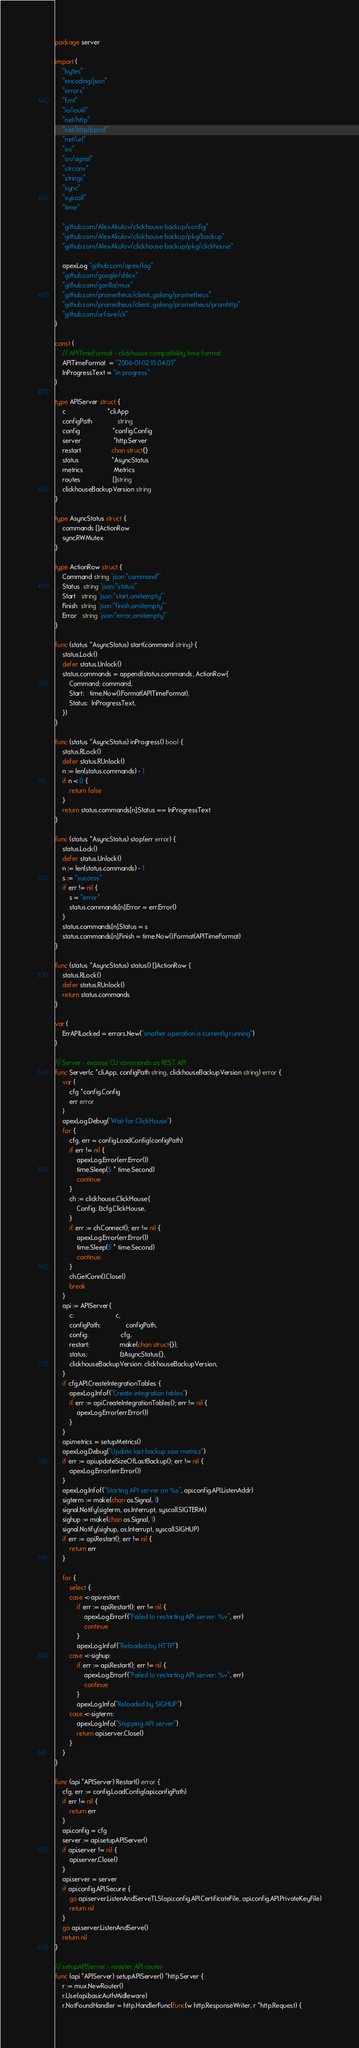Convert code to text. <code><loc_0><loc_0><loc_500><loc_500><_Go_>package server

import (
	"bytes"
	"encoding/json"
	"errors"
	"fmt"
	"io/ioutil"
	"net/http"
	"net/http/pprof"
	"net/url"
	"os"
	"os/signal"
	"strconv"
	"strings"
	"sync"
	"syscall"
	"time"

	"github.com/AlexAkulov/clickhouse-backup/config"
	"github.com/AlexAkulov/clickhouse-backup/pkg/backup"
	"github.com/AlexAkulov/clickhouse-backup/pkg/clickhouse"

	apexLog "github.com/apex/log"
	"github.com/google/shlex"
	"github.com/gorilla/mux"
	"github.com/prometheus/client_golang/prometheus"
	"github.com/prometheus/client_golang/prometheus/promhttp"
	"github.com/urfave/cli"
)

const (
	// APITimeFormat - clickhouse compatibility time format
	APITimeFormat  = "2006-01-02 15:04:05"
	InProgressText = "in progress"
)

type APIServer struct {
	c                       *cli.App
	configPath              string
	config                  *config.Config
	server                  *http.Server
	restart                 chan struct{}
	status                  *AsyncStatus
	metrics                 Metrics
	routes                  []string
	clickhouseBackupVersion string
}

type AsyncStatus struct {
	commands []ActionRow
	sync.RWMutex
}

type ActionRow struct {
	Command string `json:"command"`
	Status  string `json:"status"`
	Start   string `json:"start,omitempty"`
	Finish  string `json:"finish,omitempty"`
	Error   string `json:"error,omitempty"`
}

func (status *AsyncStatus) start(command string) {
	status.Lock()
	defer status.Unlock()
	status.commands = append(status.commands, ActionRow{
		Command: command,
		Start:   time.Now().Format(APITimeFormat),
		Status:  InProgressText,
	})
}

func (status *AsyncStatus) inProgress() bool {
	status.RLock()
	defer status.RUnlock()
	n := len(status.commands) - 1
	if n < 0 {
		return false
	}
	return status.commands[n].Status == InProgressText
}

func (status *AsyncStatus) stop(err error) {
	status.Lock()
	defer status.Unlock()
	n := len(status.commands) - 1
	s := "success"
	if err != nil {
		s = "error"
		status.commands[n].Error = err.Error()
	}
	status.commands[n].Status = s
	status.commands[n].Finish = time.Now().Format(APITimeFormat)
}

func (status *AsyncStatus) status() []ActionRow {
	status.RLock()
	defer status.RUnlock()
	return status.commands
}

var (
	ErrAPILocked = errors.New("another operation is currently running")
)

// Server - expose CLI commands as REST API
func Server(c *cli.App, configPath string, clickhouseBackupVersion string) error {
	var (
		cfg *config.Config
		err error
	)
	apexLog.Debug("Wait for ClickHouse")
	for {
		cfg, err = config.LoadConfig(configPath)
		if err != nil {
			apexLog.Error(err.Error())
			time.Sleep(5 * time.Second)
			continue
		}
		ch := clickhouse.ClickHouse{
			Config: &cfg.ClickHouse,
		}
		if err := ch.Connect(); err != nil {
			apexLog.Error(err.Error())
			time.Sleep(5 * time.Second)
			continue
		}
		ch.GetConn().Close()
		break
	}
	api := APIServer{
		c:                       c,
		configPath:              configPath,
		config:                  cfg,
		restart:                 make(chan struct{}),
		status:                  &AsyncStatus{},
		clickhouseBackupVersion: clickhouseBackupVersion,
	}
	if cfg.API.CreateIntegrationTables {
		apexLog.Infof("Create integration tables")
		if err := api.CreateIntegrationTables(); err != nil {
			apexLog.Error(err.Error())
		}
	}
	api.metrics = setupMetrics()
	apexLog.Debug("Update last backup size metrics")
	if err := api.updateSizeOfLastBackup(); err != nil {
		apexLog.Error(err.Error())
	}
	apexLog.Infof("Starting API server on %s", api.config.API.ListenAddr)
	sigterm := make(chan os.Signal, 1)
	signal.Notify(sigterm, os.Interrupt, syscall.SIGTERM)
	sighup := make(chan os.Signal, 1)
	signal.Notify(sighup, os.Interrupt, syscall.SIGHUP)
	if err := api.Restart(); err != nil {
		return err
	}

	for {
		select {
		case <-api.restart:
			if err := api.Restart(); err != nil {
				apexLog.Errorf("Failed to restarting API server: %v", err)
				continue
			}
			apexLog.Infof("Reloaded by HTTP")
		case <-sighup:
			if err := api.Restart(); err != nil {
				apexLog.Errorf("Failed to restarting API server: %v", err)
				continue
			}
			apexLog.Info("Reloaded by SIGHUP")
		case <-sigterm:
			apexLog.Info("Stopping API server")
			return api.server.Close()
		}
	}
}

func (api *APIServer) Restart() error {
	cfg, err := config.LoadConfig(api.configPath)
	if err != nil {
		return err
	}
	api.config = cfg
	server := api.setupAPIServer()
	if api.server != nil {
		api.server.Close()
	}
	api.server = server
	if api.config.API.Secure {
		go api.server.ListenAndServeTLS(api.config.API.CertificateFile, api.config.API.PrivateKeyFile)
		return nil
	}
	go api.server.ListenAndServe()
	return nil
}

// setupAPIServer - resister API routes
func (api *APIServer) setupAPIServer() *http.Server {
	r := mux.NewRouter()
	r.Use(api.basicAuthMidleware)
	r.NotFoundHandler = http.HandlerFunc(func(w http.ResponseWriter, r *http.Request) {</code> 